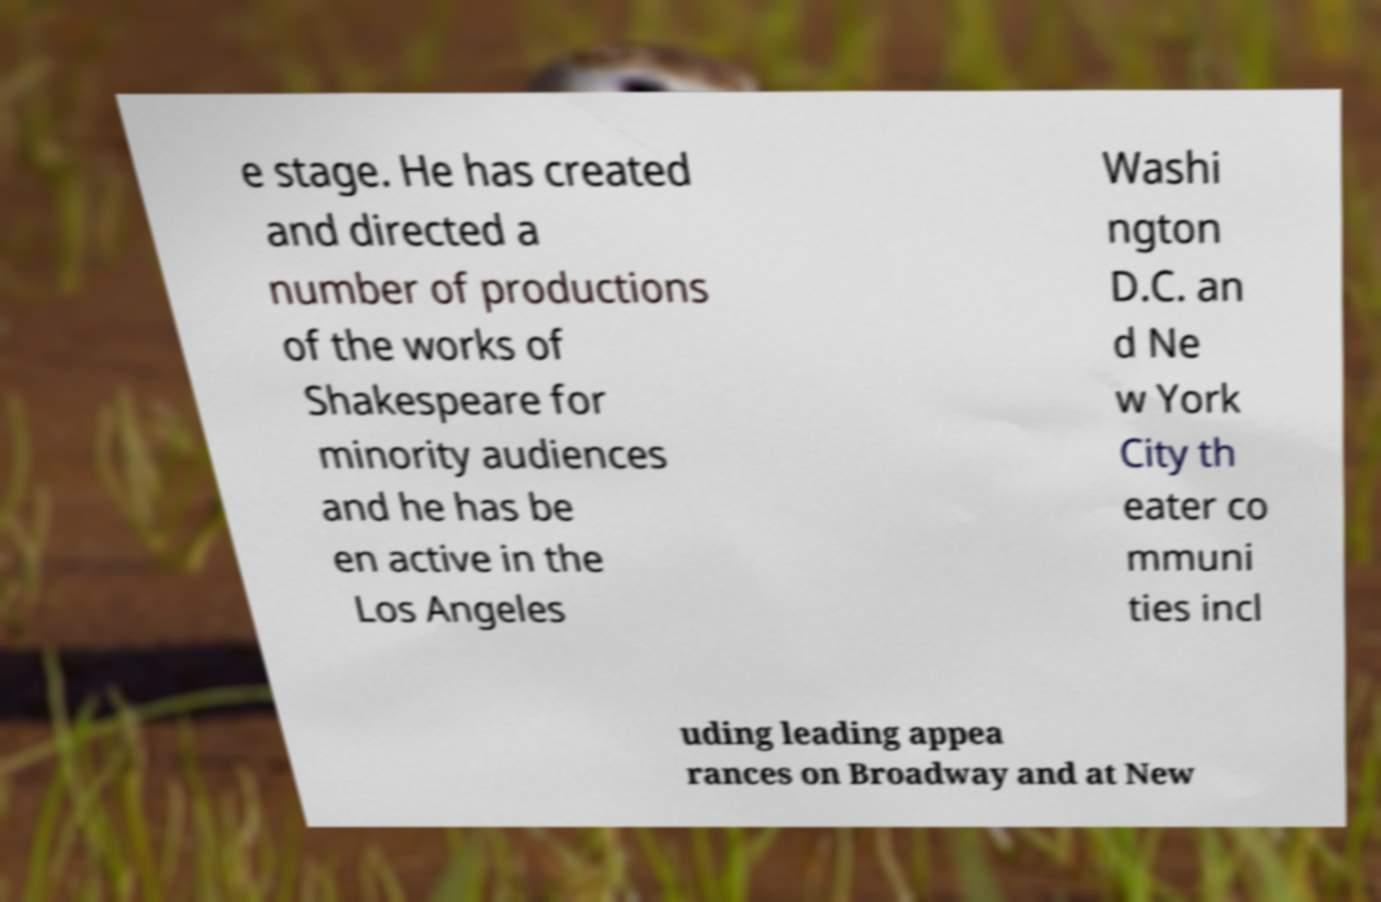I need the written content from this picture converted into text. Can you do that? e stage. He has created and directed a number of productions of the works of Shakespeare for minority audiences and he has be en active in the Los Angeles Washi ngton D.C. an d Ne w York City th eater co mmuni ties incl uding leading appea rances on Broadway and at New 